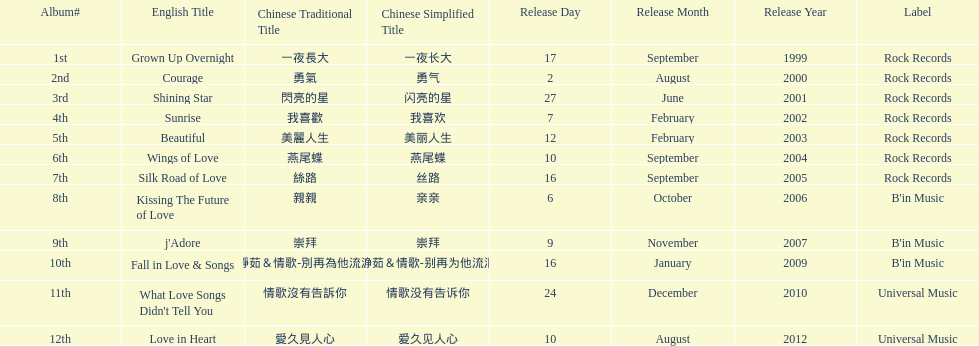What is the name of her last album produced with rock records? Silk Road of Love. 